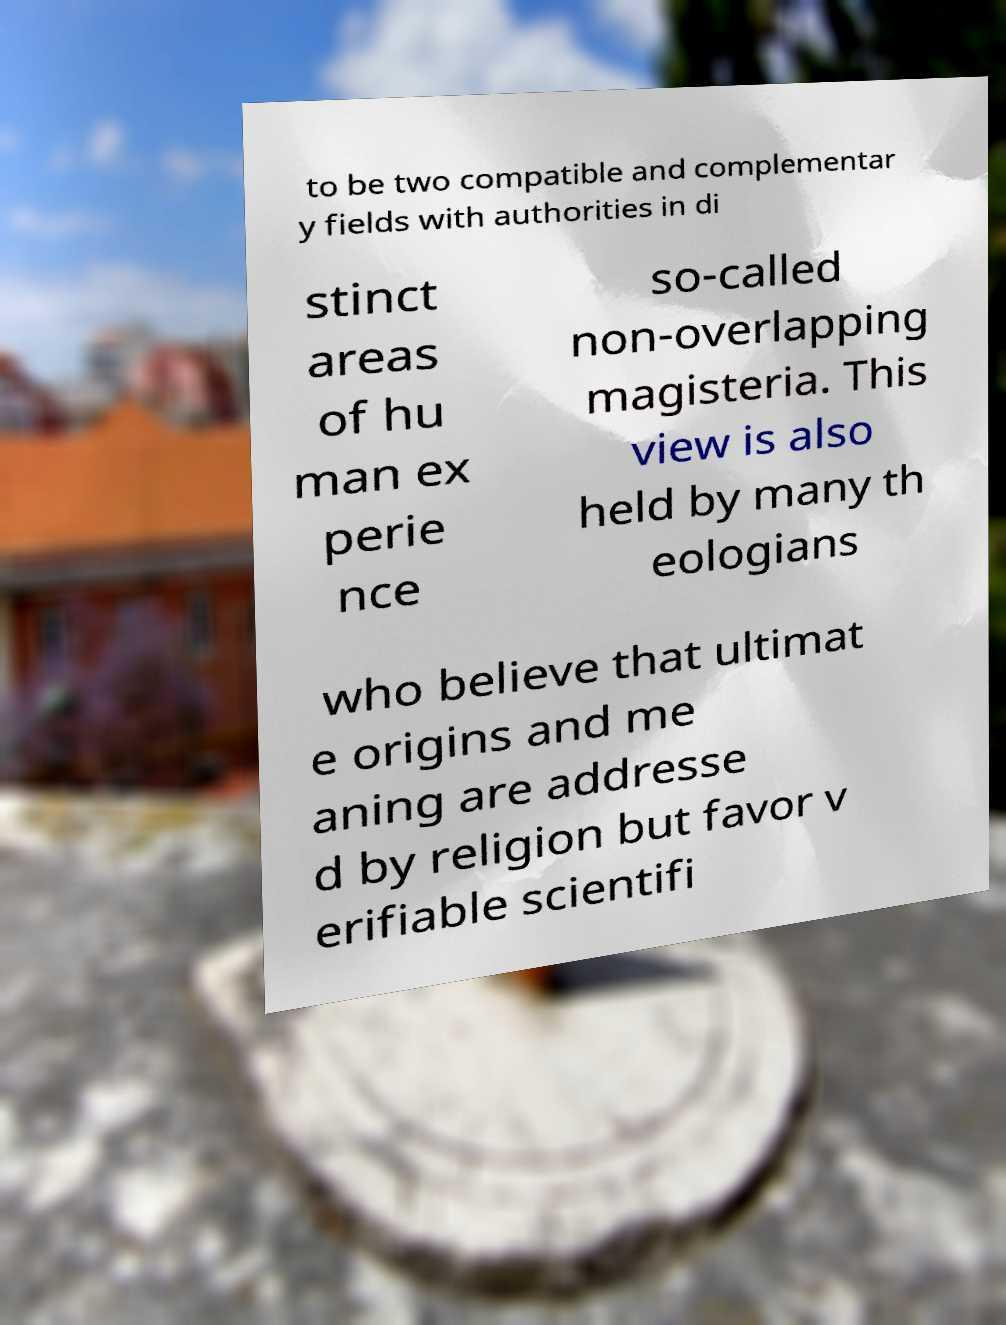Can you read and provide the text displayed in the image?This photo seems to have some interesting text. Can you extract and type it out for me? to be two compatible and complementar y fields with authorities in di stinct areas of hu man ex perie nce so-called non-overlapping magisteria. This view is also held by many th eologians who believe that ultimat e origins and me aning are addresse d by religion but favor v erifiable scientifi 